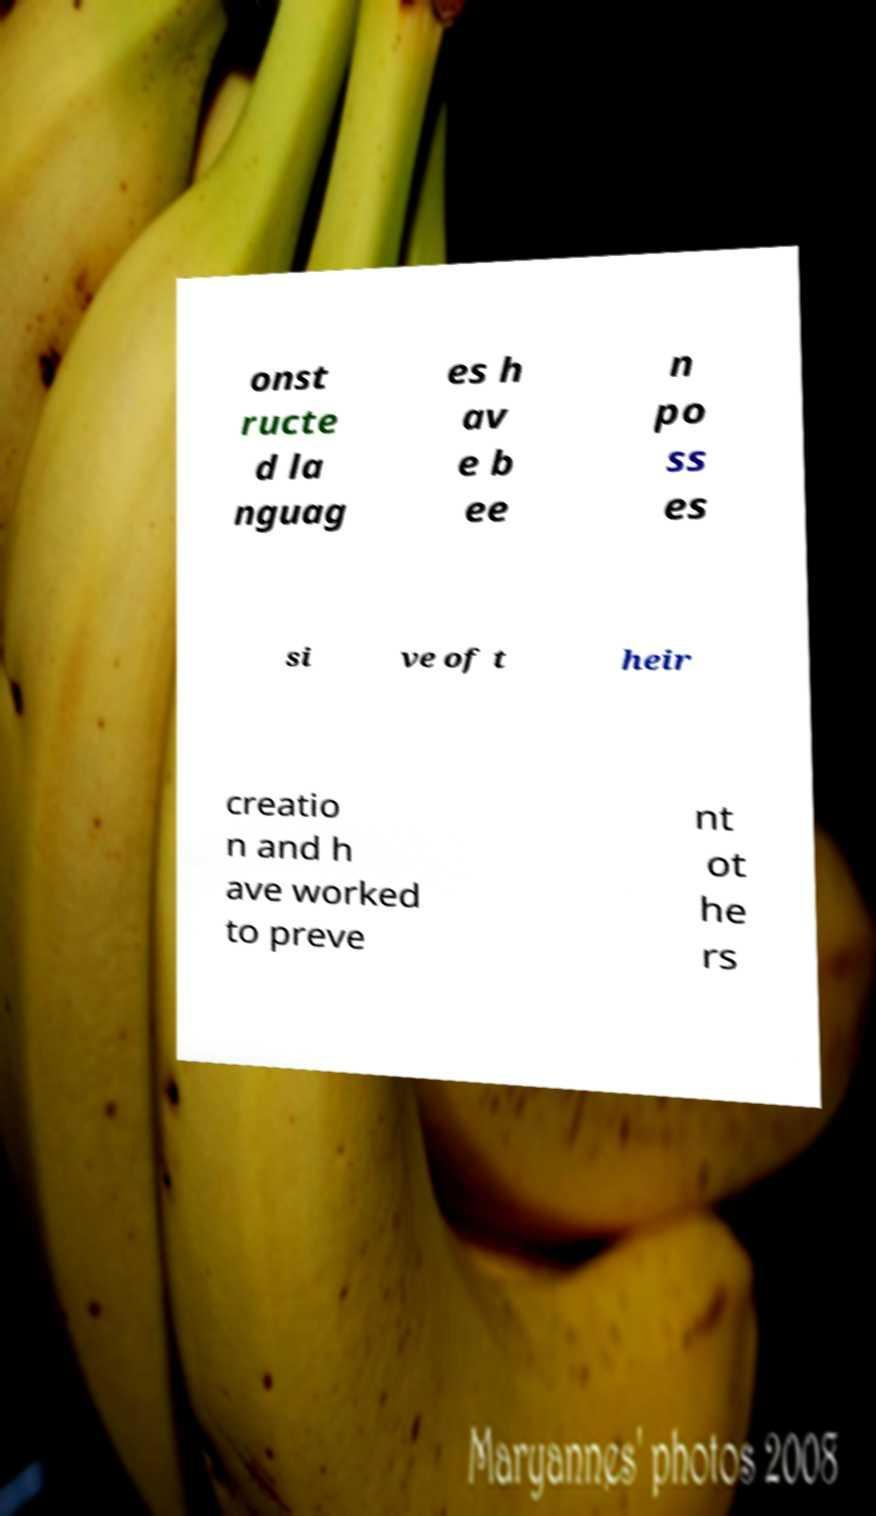Could you assist in decoding the text presented in this image and type it out clearly? onst ructe d la nguag es h av e b ee n po ss es si ve of t heir creatio n and h ave worked to preve nt ot he rs 